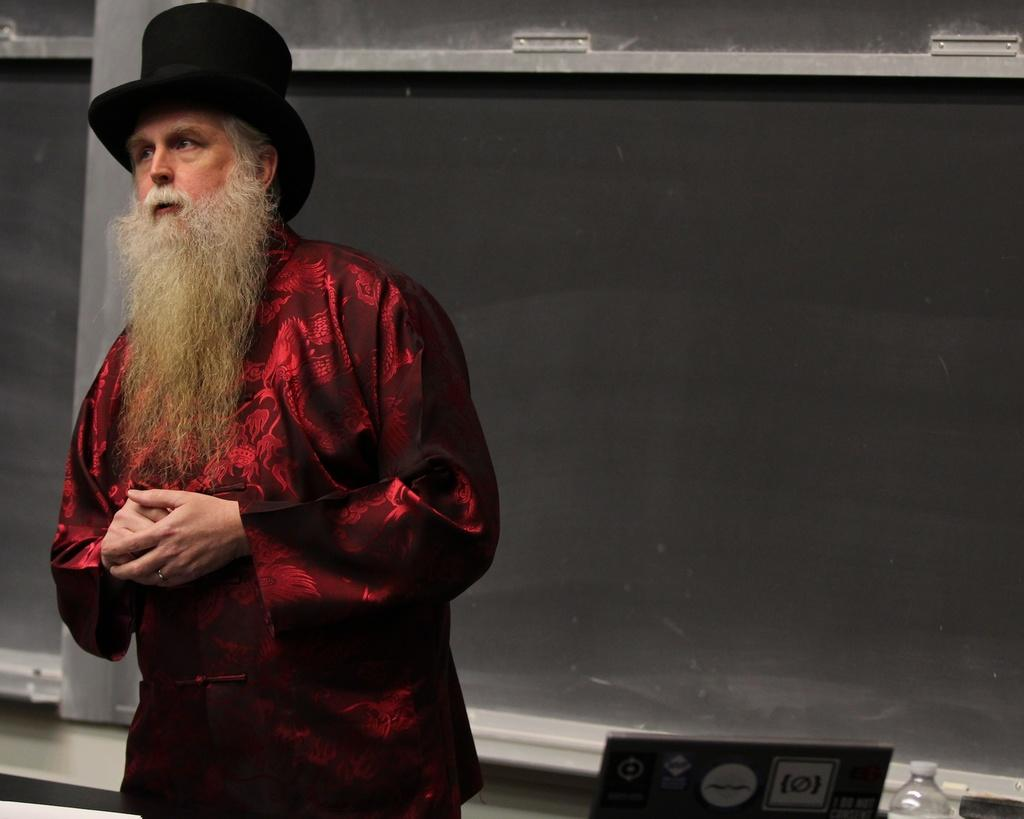Who is present in the image? There is a man in the image. Where is the man located in the image? The man is on the left side of the image. What object can be seen in the bottom right side of the image? There is a water bottle in the bottom right side of the image. What type of boat can be seen in the image? There is no boat present in the image. Can you describe the bedroom in the image? There is no bedroom present in the image. 